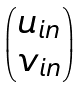Convert formula to latex. <formula><loc_0><loc_0><loc_500><loc_500>\begin{pmatrix} u _ { i n } \\ v _ { i n } \end{pmatrix}</formula> 